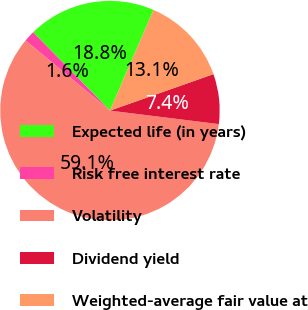Convert chart. <chart><loc_0><loc_0><loc_500><loc_500><pie_chart><fcel>Expected life (in years)<fcel>Risk free interest rate<fcel>Volatility<fcel>Dividend yield<fcel>Weighted-average fair value at<nl><fcel>18.84%<fcel>1.62%<fcel>59.07%<fcel>7.36%<fcel>13.1%<nl></chart> 